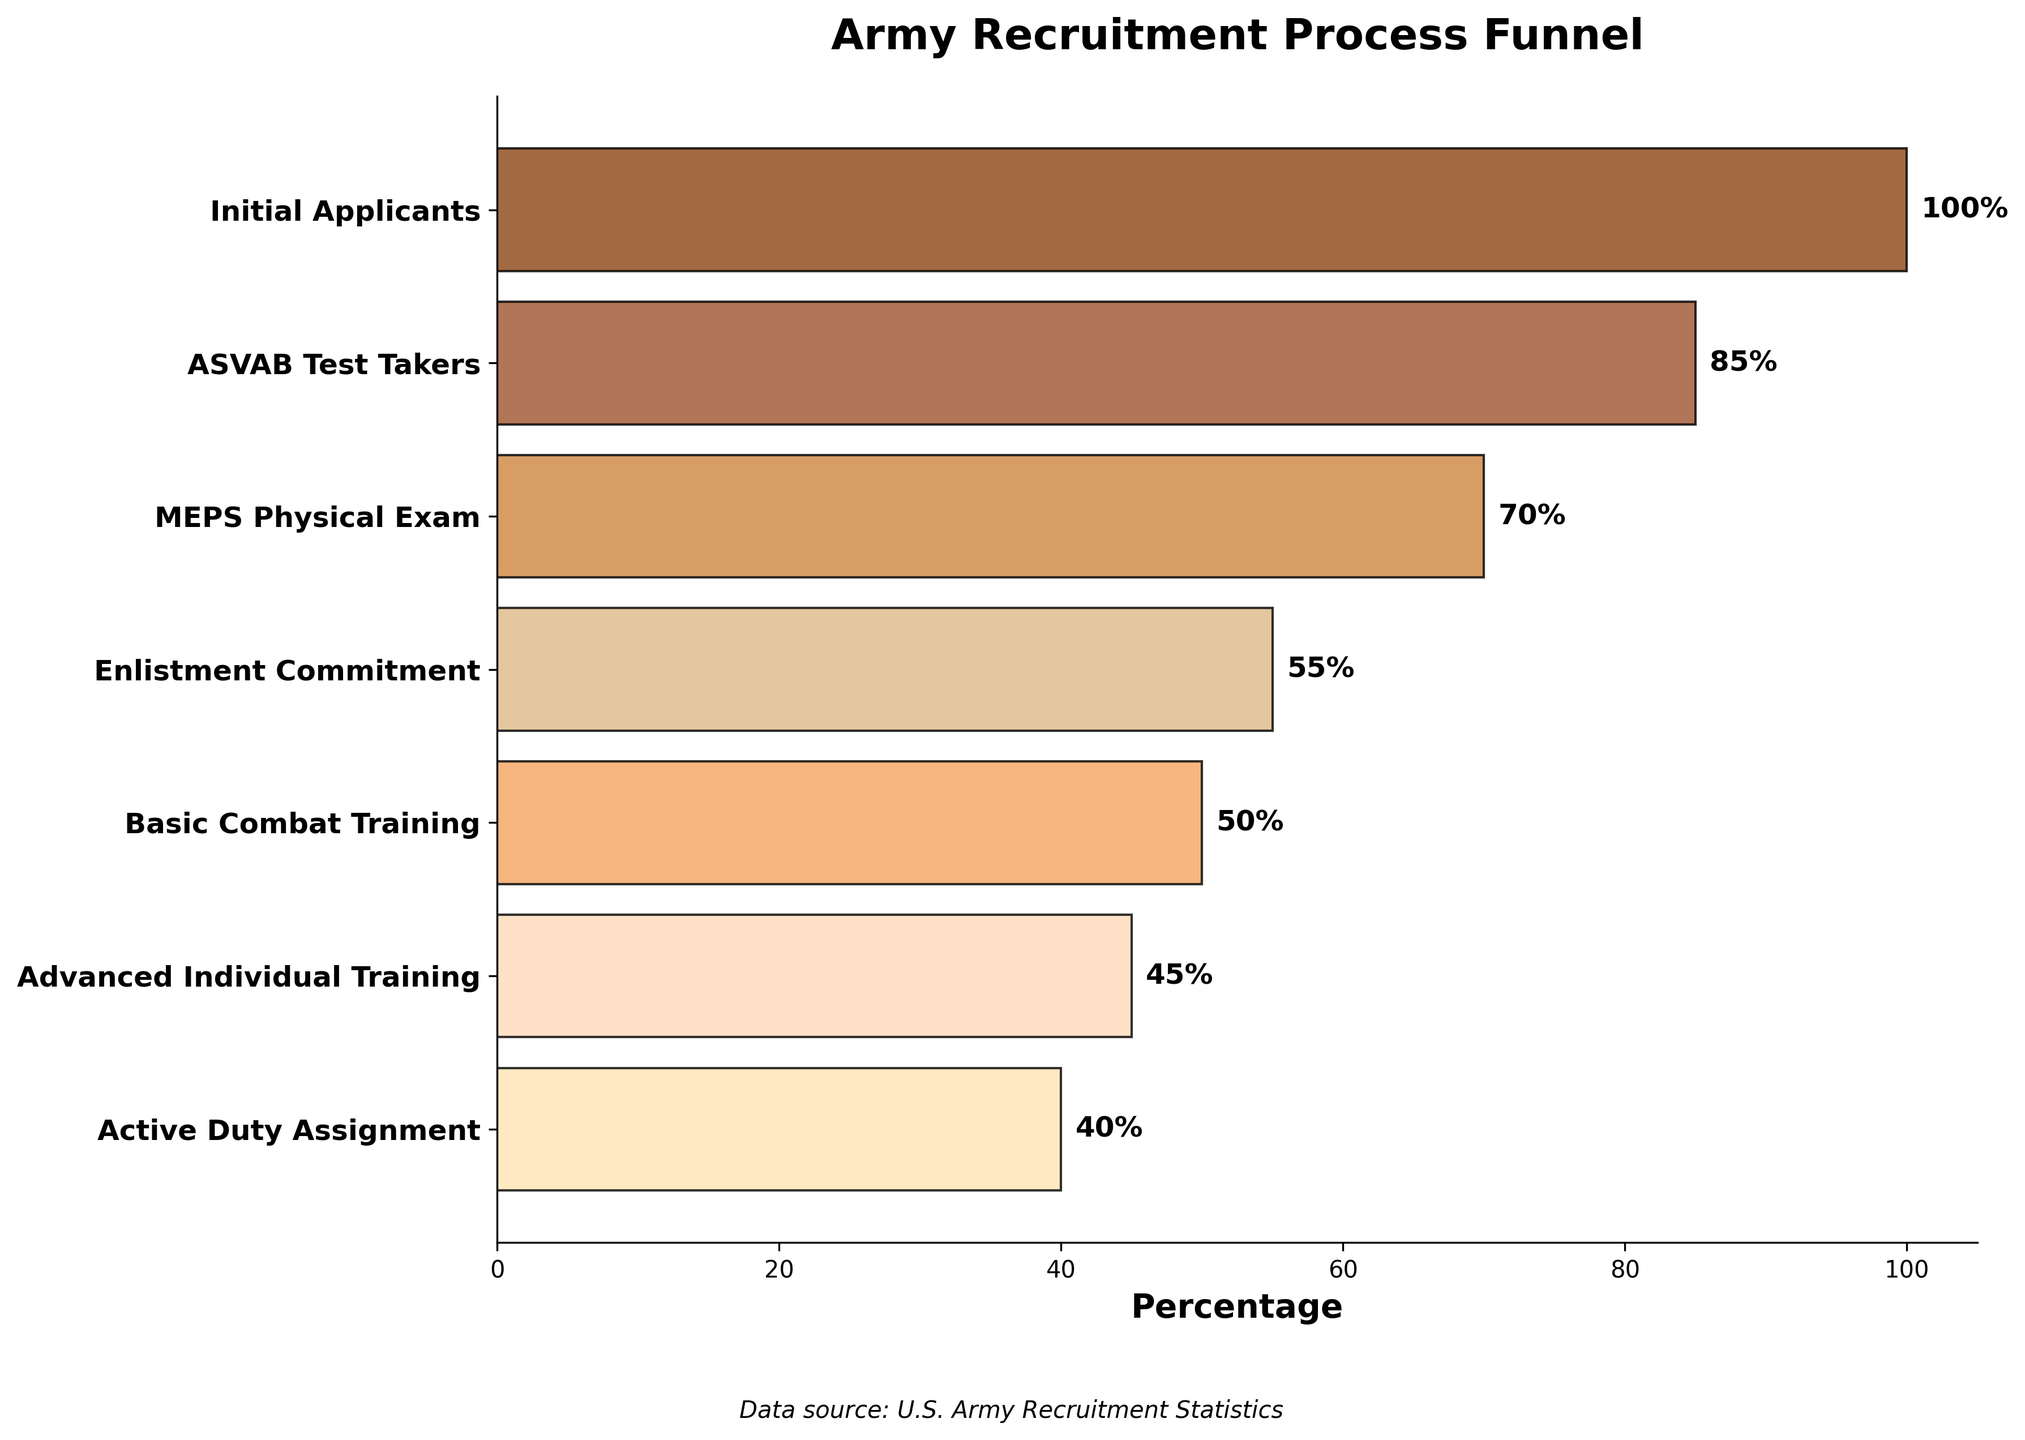what is the title of the funnel chart? The title of a chart is usually located at the top and describes what the chart is about. In this case, the title at the top reads "Army Recruitment Process Funnel," which clearly indicates the chart's focus.
Answer: Army Recruitment Process Funnel what are the labels on the y-axis? The y-axis labels usually describe the different categories or steps involved in the chart. Here, the y-axis labels represent the various steps in the Army recruitment process: Initial Applicants, ASVAB Test Takers, MEPS Physical Exam, Enlistment Commitment, Basic Combat Training, Advanced Individual Training, and Active Duty Assignment.
Answer: Initial Applicants, ASVAB Test Takers, MEPS Physical Exam, Enlistment Commitment, Basic Combat Training, Advanced Individual Training, Active Duty Assignment what percentage of initial applicants progress to enlistment commitment? To find the percentage of initial applicants who progress to the enlistment commitment stage, look at the data points at both steps. Initial Applicants start at 100%, and Enlistment Commitment is at 55%.
Answer: 55% how many steps are involved in the army recruitment process as shown in the chart? The number of steps can be counted by looking at the y-axis labels. In this chart, there are seven steps: Initial Applicants, ASVAB Test Takers, MEPS Physical Exam, Enlistment Commitment, Basic Combat Training, Advanced Individual Training, and Active Duty Assignment.
Answer: 7 which step sees the largest drop in percentage from the previous step? To find the largest drop, calculate the differences between adjacent steps and compare them. The drop from Initial Applicants (100%) to ASVAB Test Takers (85%) is 15%, from ASVAB to MEPS Exam (70%) is 15%, from MEPS to Enlistment (55%) is 15%, from Enlistment to Basic Training (50%) is 5%, from Basic Training to Advanced Training (45%) is 5%, and from Advanced Training to Active Duty (40%) is 5%. The largest drop is from Initial Applicants to ASVAB, ASVAB to MEPS, and MEPS to Enlistment, all by 15%.
Answer: Initial Applicants to ASVAB, ASVAB to MEPS, MEPS to Enlistment what is the average percentage retention from initial applicants to active duty assignment? The retention percentages at each step are given: 100%, 85%, 70%, 55%, 50%, 45%, and 40%. To find the average, add these percentages and divide by the number of steps: (100 + 85 + 70 + 55 + 50 + 45 + 40) / 7 = 445 / 7 ≈ 63.57%.
Answer: 63.57% by what percentage does the number of candidates decrease on average at each step? To find the average percentage decrease, calculate the drop at each step, add these values together, and divide by the number of steps minus one. Drops are: (100 - 85) = 15, (85 - 70) = 15, (70 - 55) = 15, (55 - 50) = 5, (50 - 45) = 5, (45 - 40) = 5. Sum is 15 + 15 + 15 + 5 + 5 + 5 = 60. Average decrease is 60 / 6 ≈ 10%.
Answer: 10% does the funnel chart suggest that the majority of applicants complete basic combat training? The funnel chart shows that 50% of the initial applicants complete Basic Combat Training, which suggests that half of the applicants make it through this stage. Since this is not more than half the applicants, the majority do not complete Basic Combat Training.
Answer: No what is the percentage of ASVAB test takers who make it to the MEPS physical exam? To find this, look at the percentages for ASVAB Test Takers and MEPS Physical Exam: 85% and 70%, respectively. Calculate the retention: (70 / 85) * 100 ≈ 82.35%.
Answer: 82.35% 